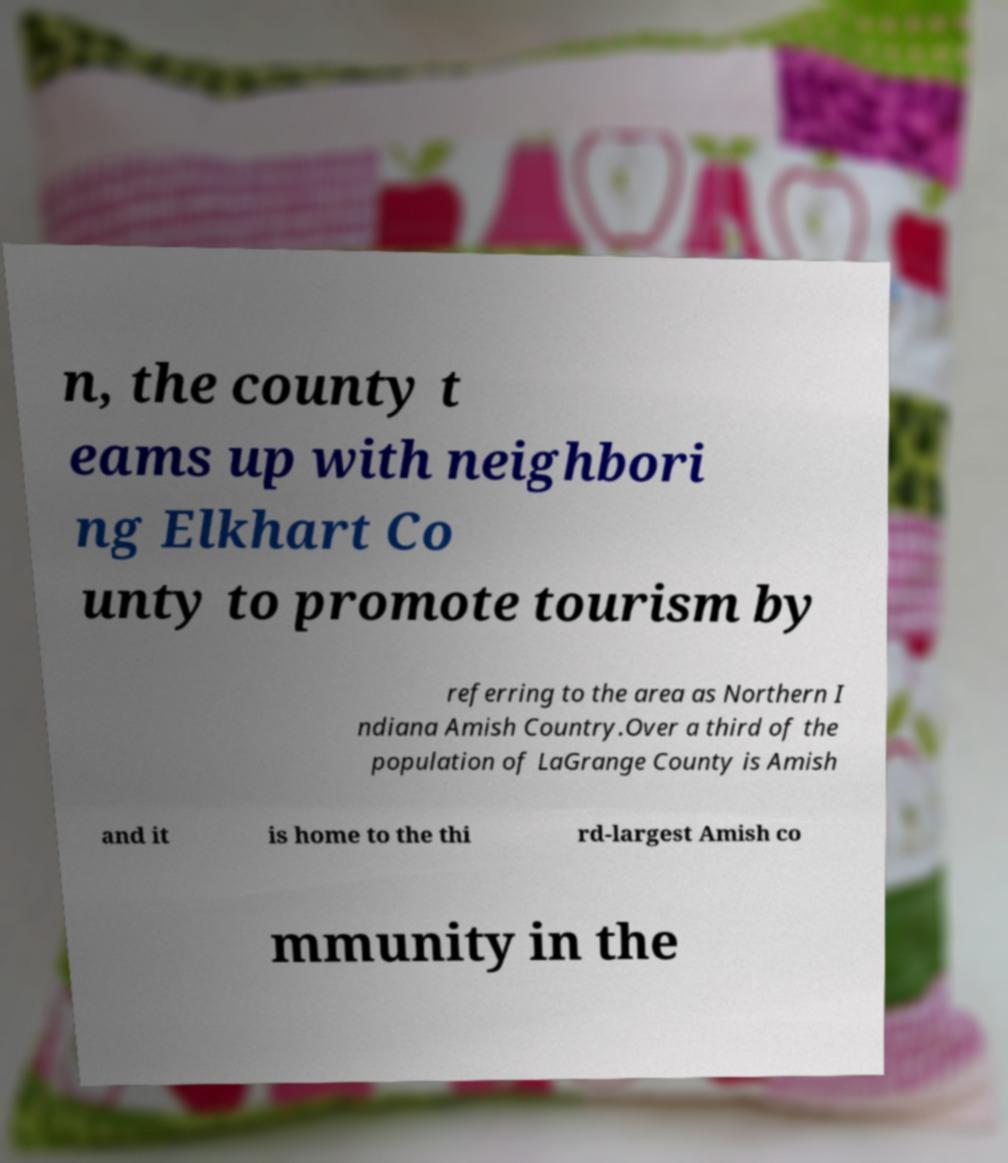There's text embedded in this image that I need extracted. Can you transcribe it verbatim? n, the county t eams up with neighbori ng Elkhart Co unty to promote tourism by referring to the area as Northern I ndiana Amish Country.Over a third of the population of LaGrange County is Amish and it is home to the thi rd-largest Amish co mmunity in the 